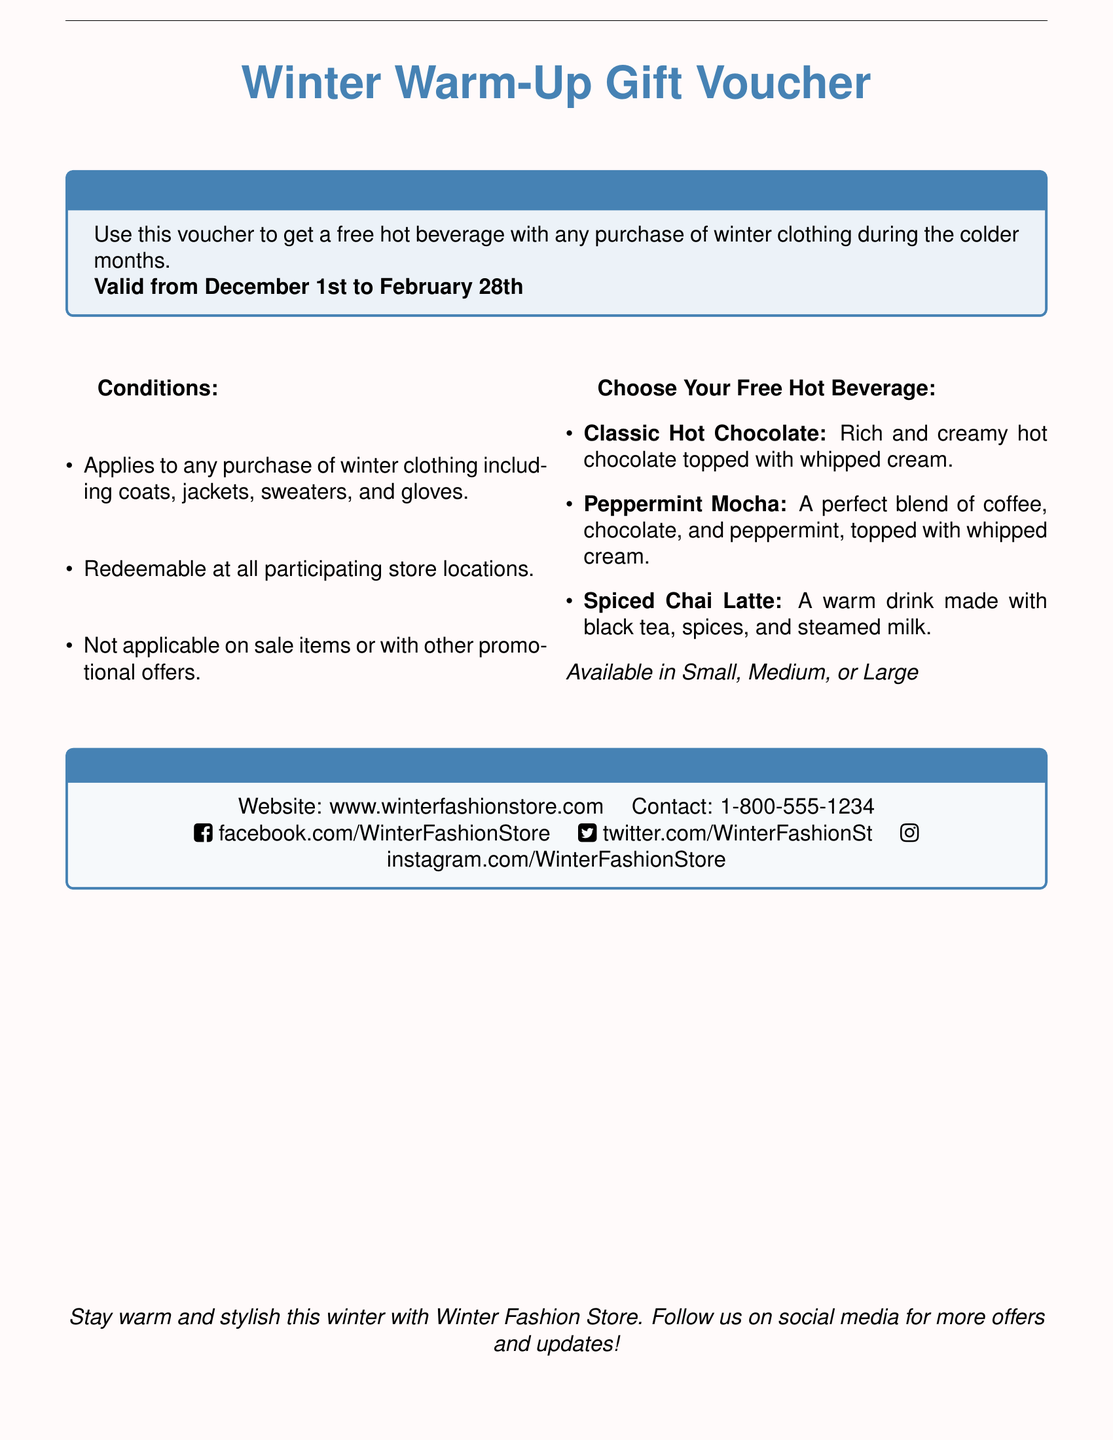What is the name of the voucher? The title of the voucher is prominently displayed at the top of the document.
Answer: Winter Warm-Up Gift Voucher What is the validity period of the voucher? The document specifies the dates during which the voucher can be used.
Answer: December 1st to February 28th What types of clothing are eligible for the voucher? The conditions list specific types of winter clothing that qualify for the offer.
Answer: Winter clothing including coats, jackets, sweaters, and gloves Can the voucher be used with other promotional offers? The conditions note restrictions on combining the voucher with certain offers.
Answer: Not applicable on sale items or with other promotional offers What beverages can you choose from with this voucher? The document lists types of hot beverages available for free with the voucher.
Answer: Classic Hot Chocolate, Peppermint Mocha, Spiced Chai Latte Where can you redeem the voucher? It specifies that the voucher is redeemable at all participating store locations.
Answer: All participating store locations What is the contact number for the Winter Fashion Store? The contact information is provided at the bottom of the voucher.
Answer: 1-800-555-1234 What sizes are the beverages available in? The document mentions the available sizes for the hot beverages.
Answer: Small, Medium, or Large 